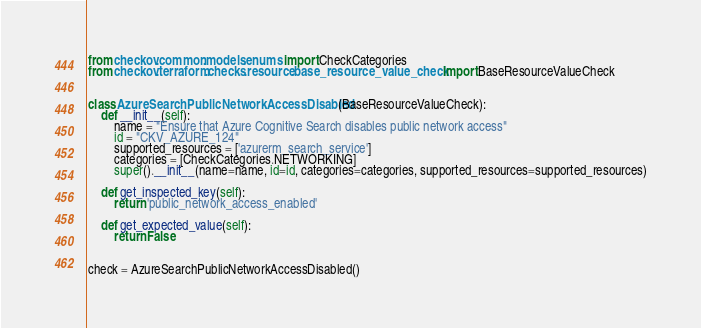Convert code to text. <code><loc_0><loc_0><loc_500><loc_500><_Python_>from checkov.common.models.enums import CheckCategories
from checkov.terraform.checks.resource.base_resource_value_check import BaseResourceValueCheck


class AzureSearchPublicNetworkAccessDisabled(BaseResourceValueCheck):
    def __init__(self):
        name = "Ensure that Azure Cognitive Search disables public network access"
        id = "CKV_AZURE_124"
        supported_resources = ['azurerm_search_service']
        categories = [CheckCategories.NETWORKING]
        super().__init__(name=name, id=id, categories=categories, supported_resources=supported_resources)

    def get_inspected_key(self):
        return 'public_network_access_enabled'

    def get_expected_value(self):
        return False


check = AzureSearchPublicNetworkAccessDisabled()
</code> 